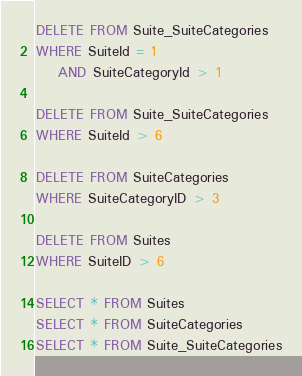Convert code to text. <code><loc_0><loc_0><loc_500><loc_500><_SQL_>DELETE FROM Suite_SuiteCategories
WHERE SuiteId = 1
	AND SuiteCategoryId > 1

DELETE FROM Suite_SuiteCategories
WHERE SuiteId > 6

DELETE FROM SuiteCategories
WHERE SuiteCategoryID > 3

DELETE FROM Suites
WHERE SuiteID > 6

SELECT * FROM Suites
SELECT * FROM SuiteCategories
SELECT * FROM Suite_SuiteCategories</code> 